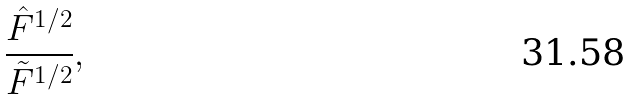Convert formula to latex. <formula><loc_0><loc_0><loc_500><loc_500>\frac { { \hat { F } } ^ { 1 / 2 } } { { \tilde { F } } ^ { 1 / 2 } } ,</formula> 